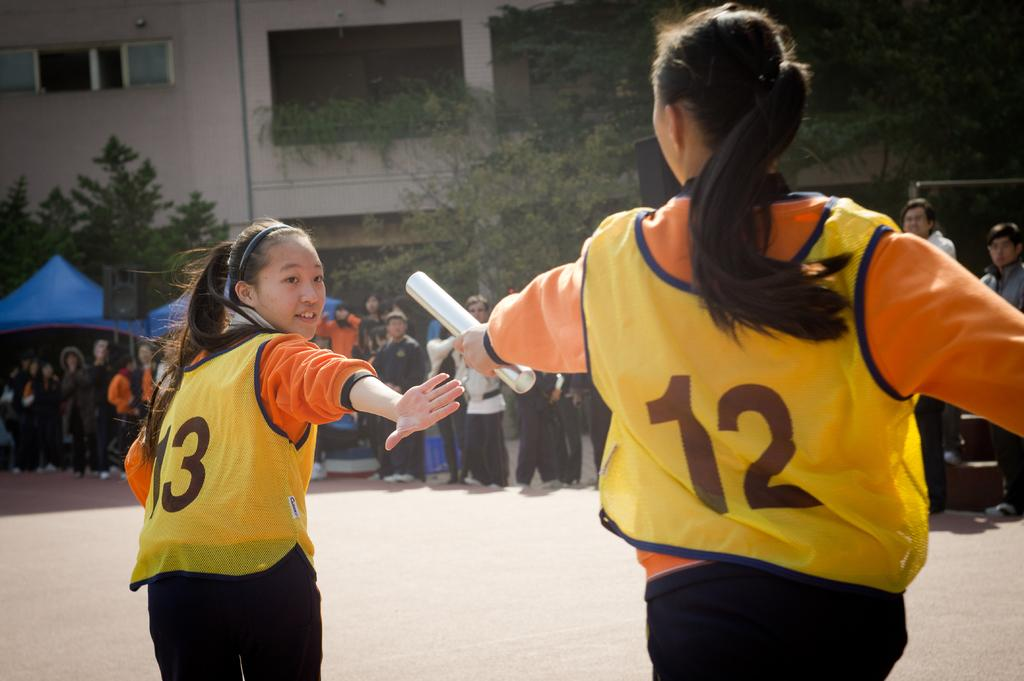<image>
Render a clear and concise summary of the photo. A runner wearing a jersey with the number 12 hands off a baton to another runner wearing number 13. 